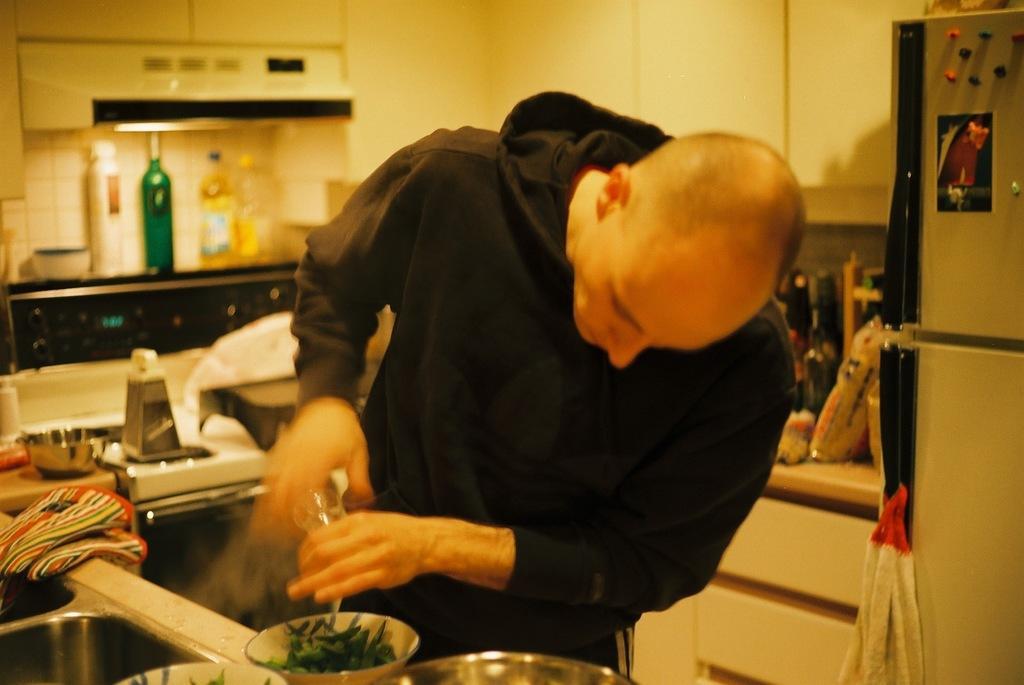How would you summarize this image in a sentence or two? In this image we can see a person holding an object, there is a bowl with food item and there are few objects on the countertop, a fridge, few cupboards and bottles. 